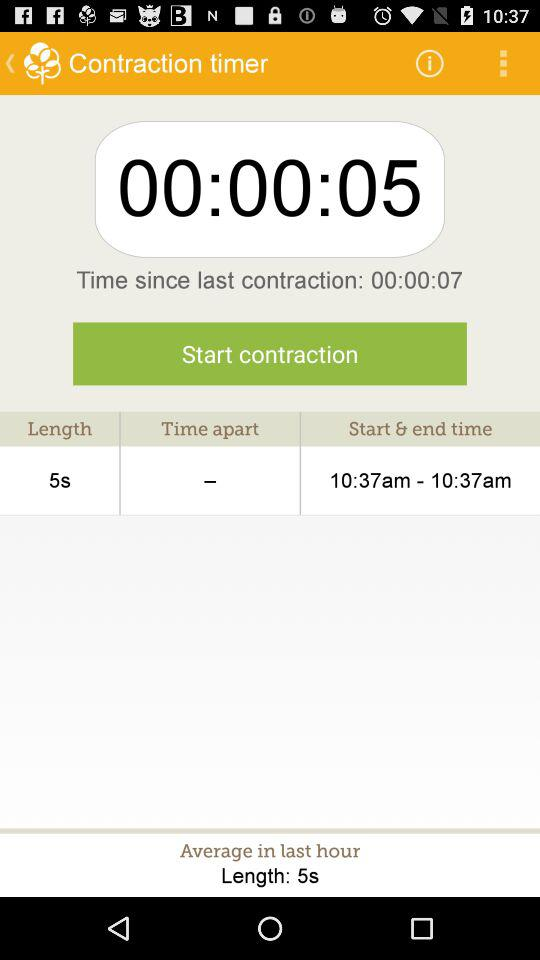At what hour is the average calculated? The average is calculated in last hour. 